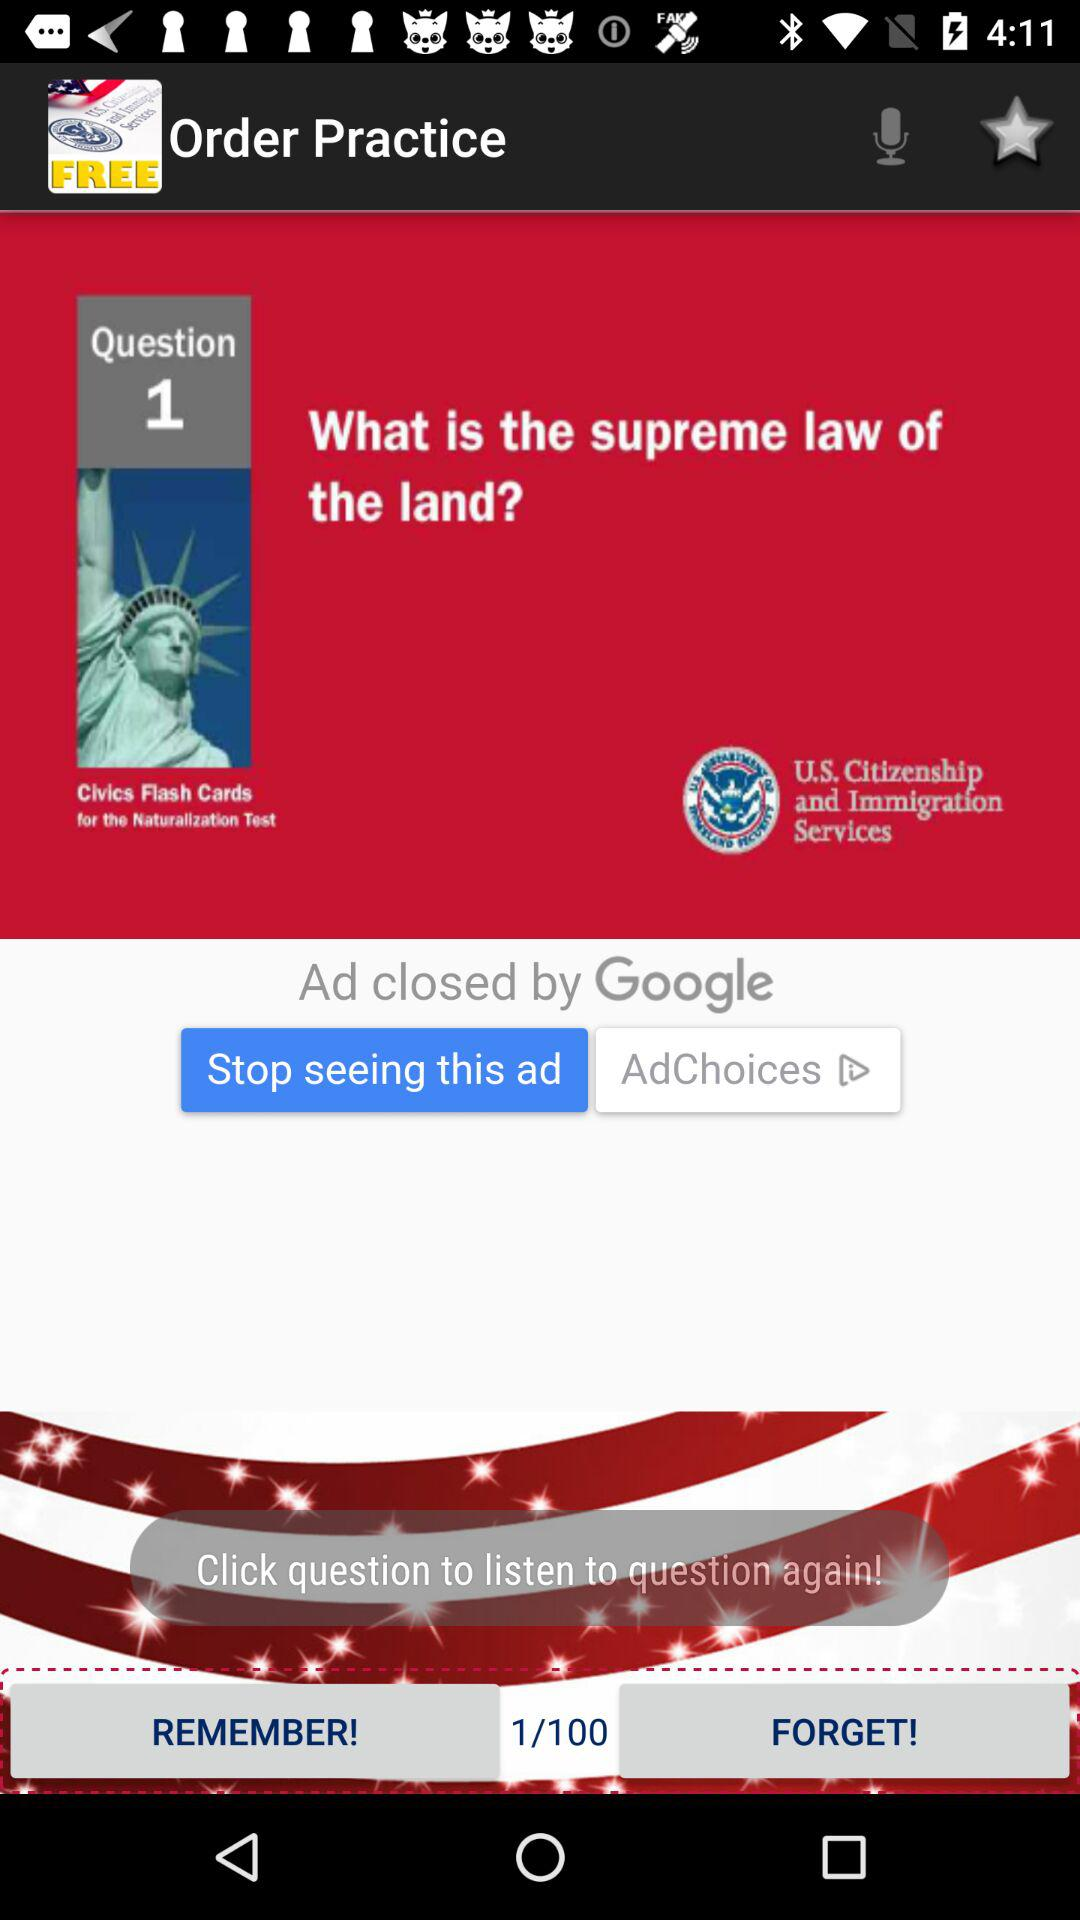What is question number 1? Question number 1 is "What is the supreme law of the land?". 